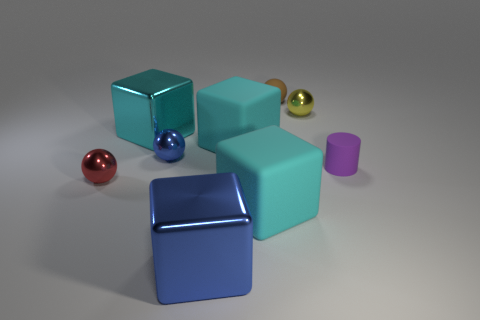How would you describe the lighting and atmosphere in this image? The lighting in the image is diffuse and soft, indicating an indoor setting with a single bright light source, perhaps overhead, creating gentle shadows that fall mostly to the right of the objects. The atmosphere is calm and clean, with no discernible background elements to suggest a specific location. The objects are well-illuminated, with some specular highlights on the shinier surfaces, like the glossy blue cube and the metallic spheres, which indicate the quality of light is quite even and not harsh. 